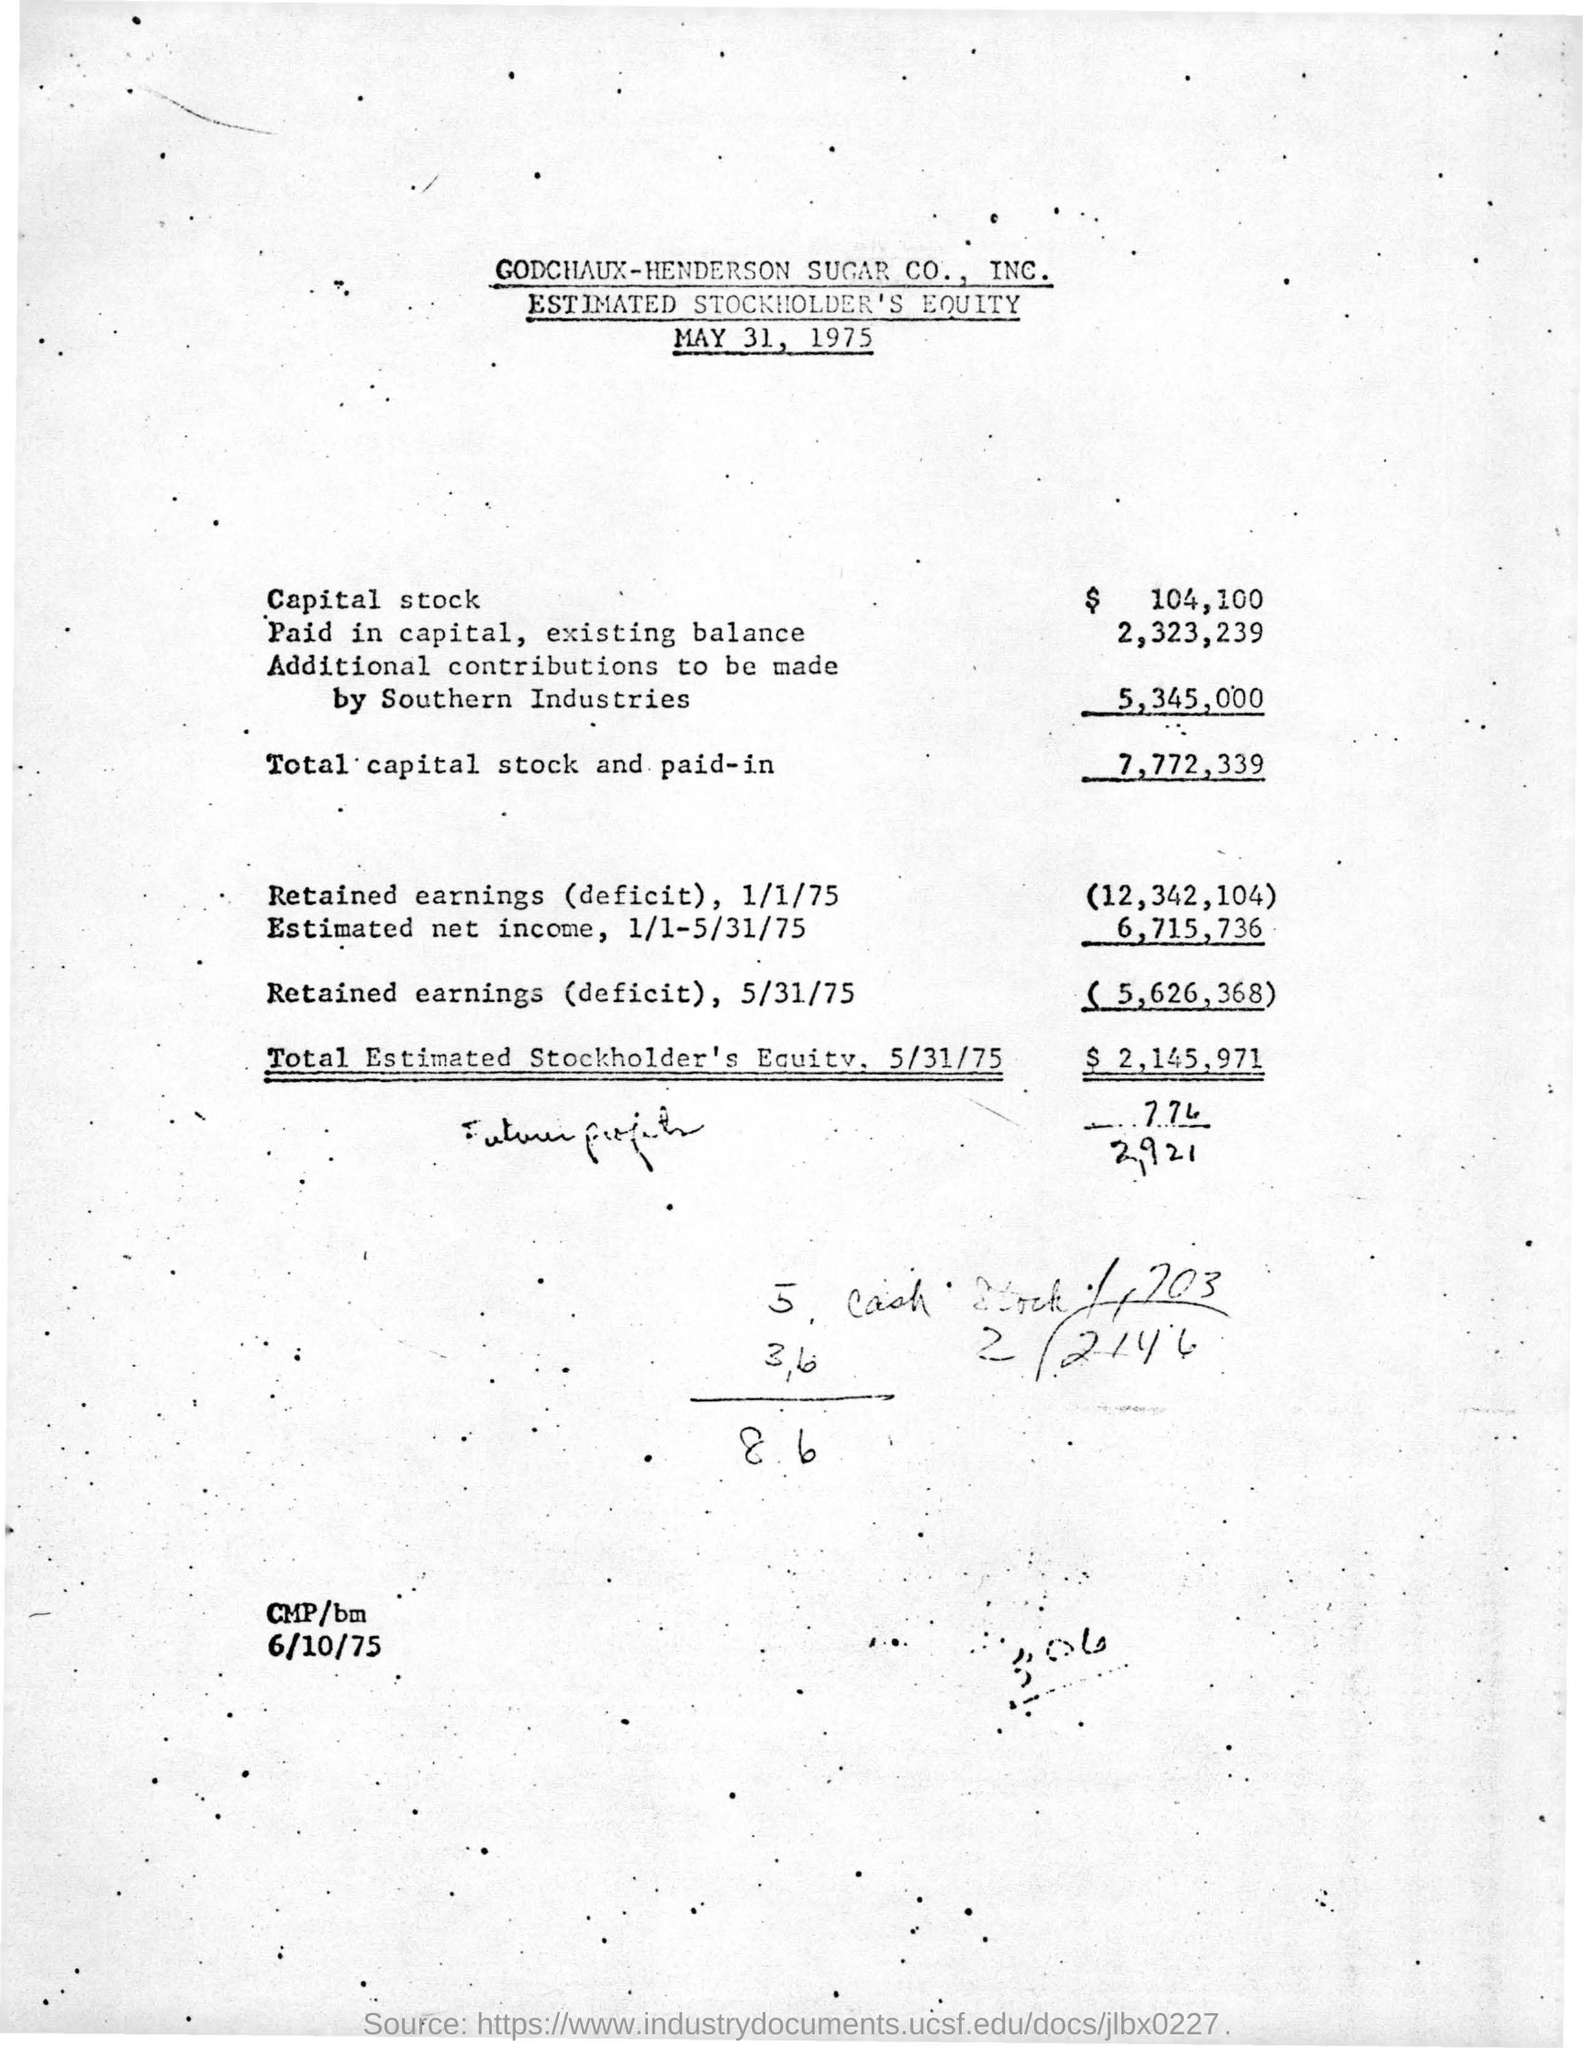Specify some key components in this picture. The total capital stock and paid-in amount is 7,772,339. The date mentioned at the bottom is 6/10/75. The date mentioned at the top is May 31, 1975. As of May 31, 1975, the estimated total stockholders' equity was $2,145,971. 